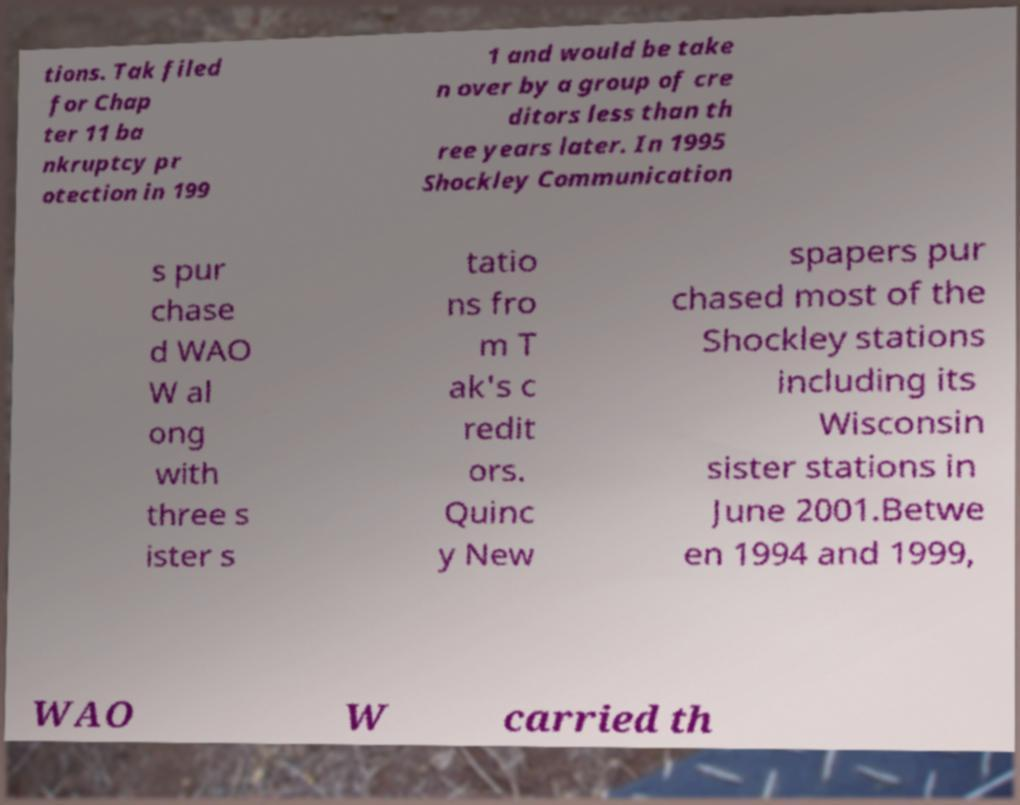Could you assist in decoding the text presented in this image and type it out clearly? tions. Tak filed for Chap ter 11 ba nkruptcy pr otection in 199 1 and would be take n over by a group of cre ditors less than th ree years later. In 1995 Shockley Communication s pur chase d WAO W al ong with three s ister s tatio ns fro m T ak's c redit ors. Quinc y New spapers pur chased most of the Shockley stations including its Wisconsin sister stations in June 2001.Betwe en 1994 and 1999, WAO W carried th 